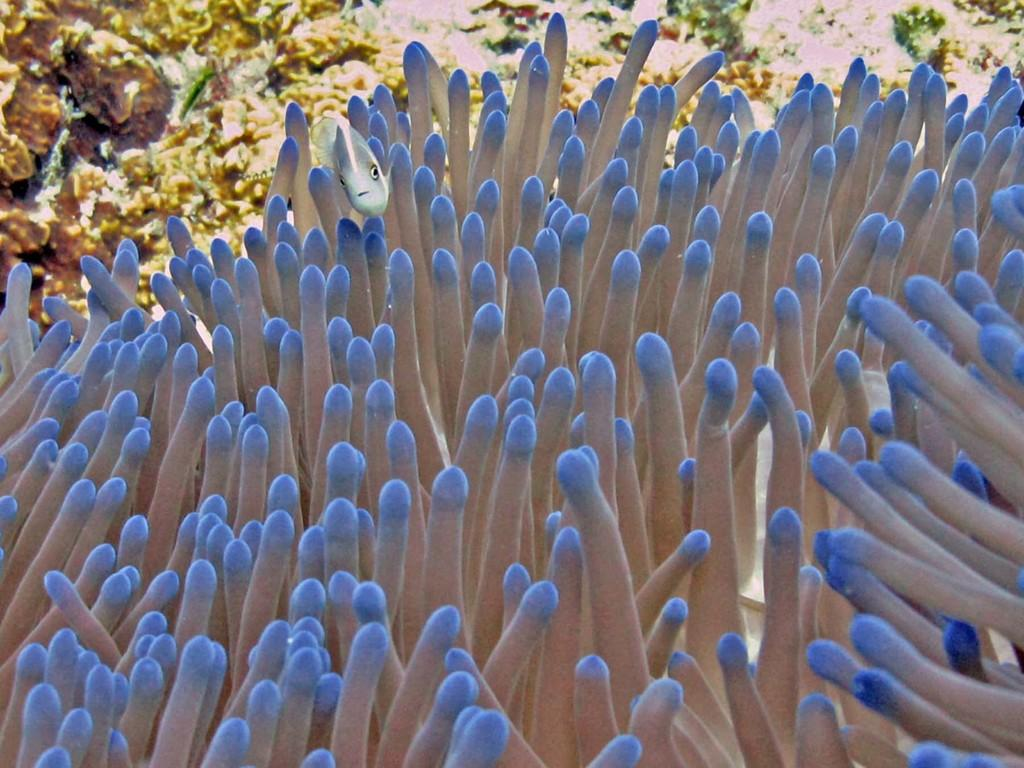What type of image is being described? The image appears to be an animated image. What can be seen in the foreground of the image? There are water plants and a fish in the foreground of the image. What is visible in the background of the image? There are coral reefs in the background of the image. What type of floor can be seen in the image? There is no floor visible in the image, as it is an animated image depicting underwater scenery. What is your opinion on the fish's appearance in the image? The question asks for an opinion, which is not based on the facts provided. Instead, we can describe the fish's appearance by saying that it is visible in the foreground of the image. 